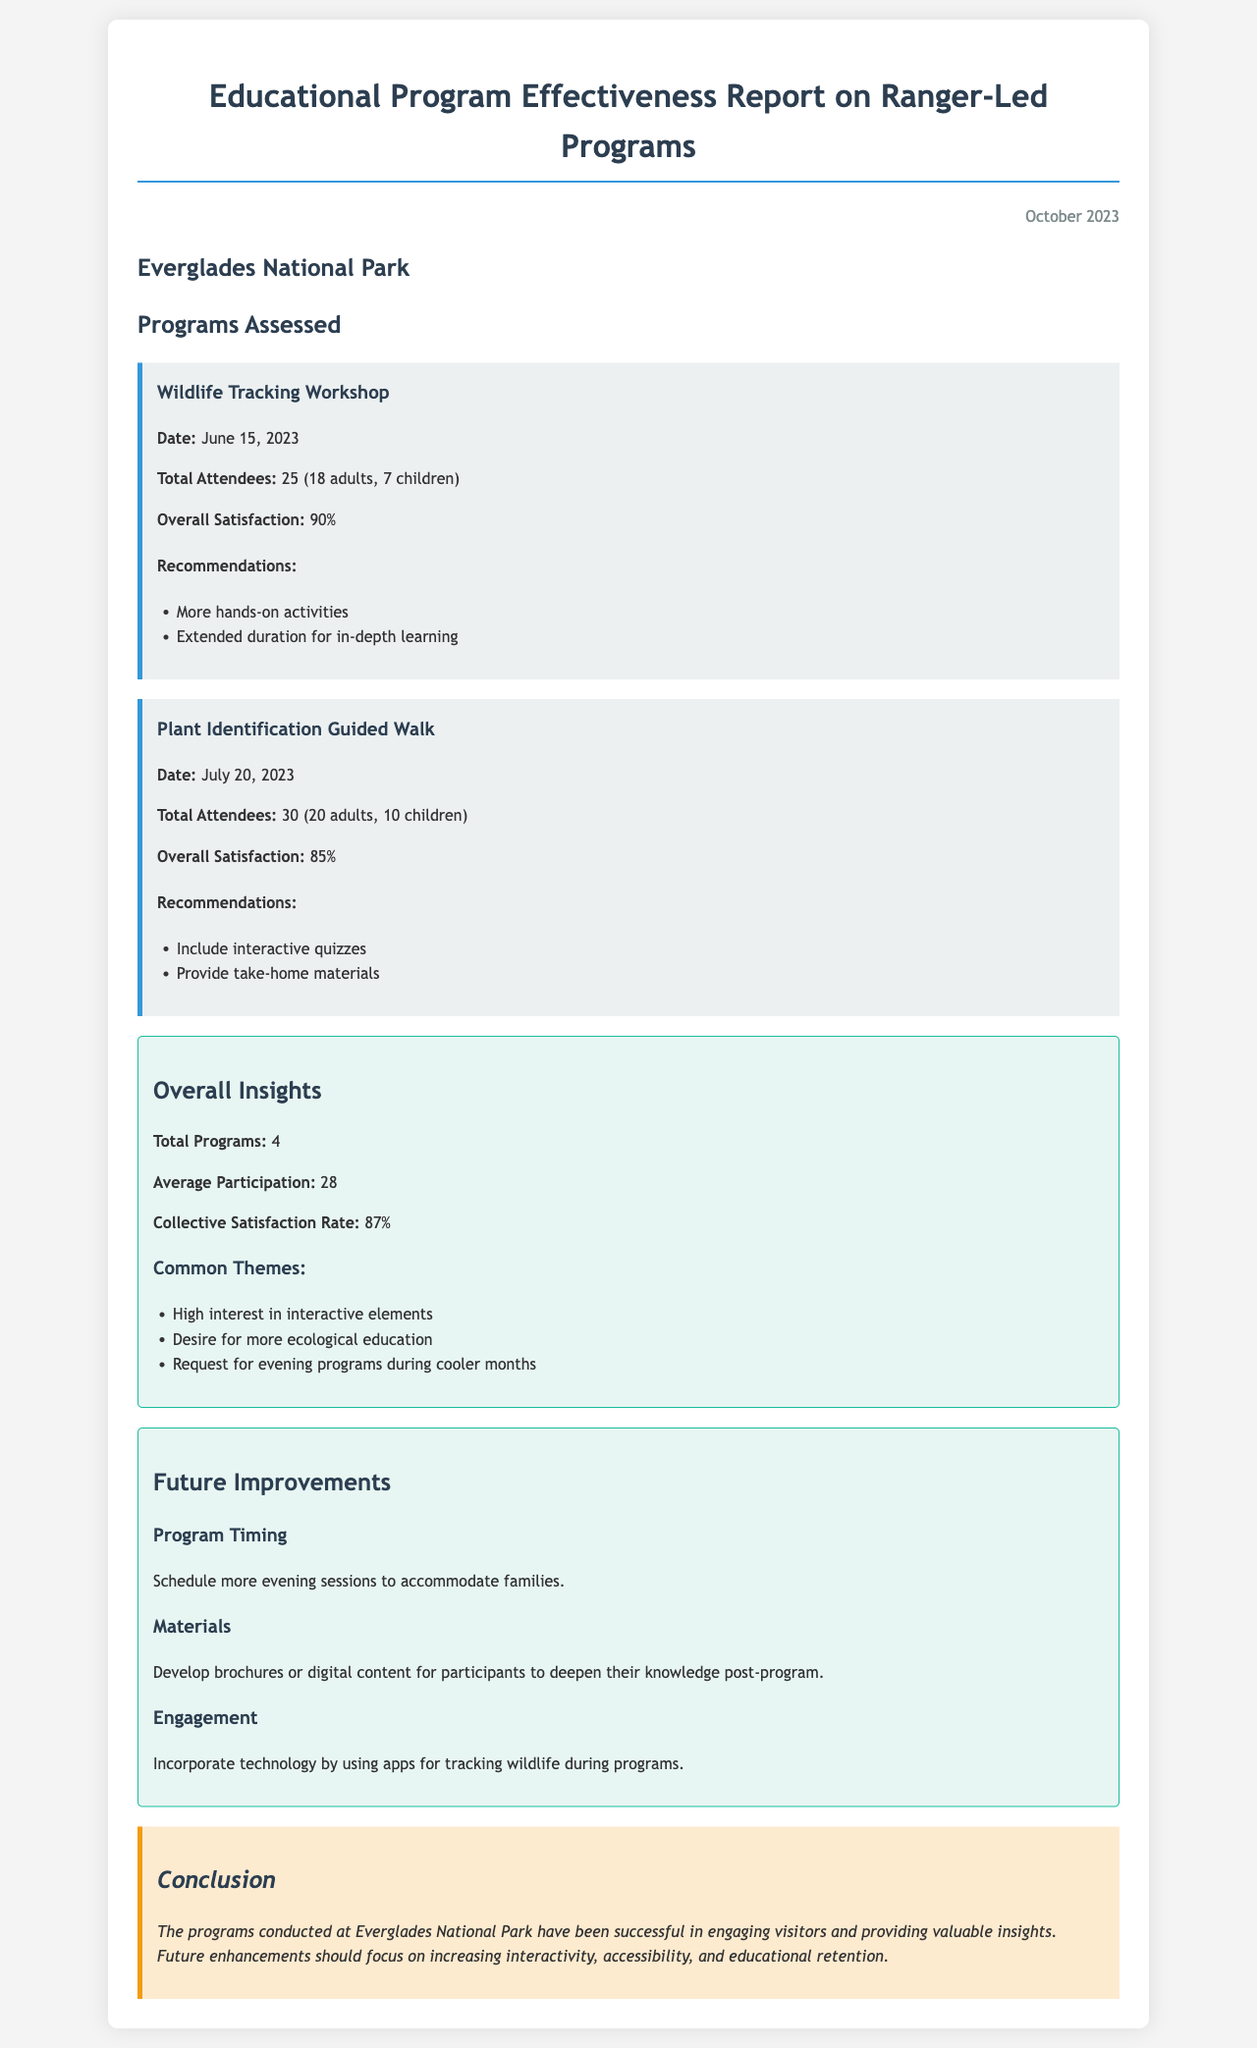What is the title of the report? The title of the report is clearly stated at the top of the document.
Answer: Educational Program Effectiveness Report on Ranger-Led Programs When was the Wildlife Tracking Workshop held? The date of the Wildlife Tracking Workshop is provided within the program details.
Answer: June 15, 2023 How many children attended the Plant Identification Guided Walk? The number of children attendees is specified in the program details for Plant Identification Guided Walk.
Answer: 10 children What is the overall satisfaction rate for the programs? The collective satisfaction rate is mentioned in the insights section of the report.
Answer: 87% What common theme was noted regarding visitor engagement? One of the common themes regarding visitor engagement is listed under overall insights.
Answer: High interest in interactive elements What future improvement is suggested regarding program timing? The suggested improvement for program timing is included in the future improvements section.
Answer: Schedule more evening sessions What materials are suggested for future programs? The improvements section mentions what types of materials are recommended for participants.
Answer: Develop brochures or digital content What is the average participation across the assessed programs? The average participation figure is provided in the overall insights.
Answer: 28 What conclusion is drawn about the effectiveness of the programs? The conclusion summarizes the overall effectiveness of the programs in relation to visitor engagement.
Answer: Successful in engaging visitors and providing valuable insights 